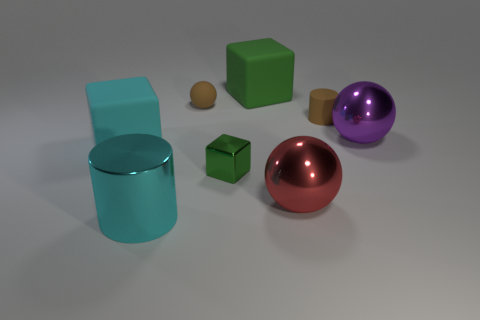Subtract all large spheres. How many spheres are left? 1 Subtract all green balls. How many green blocks are left? 2 Subtract 1 spheres. How many spheres are left? 2 Subtract all cyan balls. Subtract all cyan cylinders. How many balls are left? 3 Add 1 brown balls. How many objects exist? 9 Subtract all blocks. How many objects are left? 5 Subtract 1 cyan blocks. How many objects are left? 7 Subtract all purple metal spheres. Subtract all large red metallic balls. How many objects are left? 6 Add 8 big cyan metallic objects. How many big cyan metallic objects are left? 9 Add 8 small green things. How many small green things exist? 9 